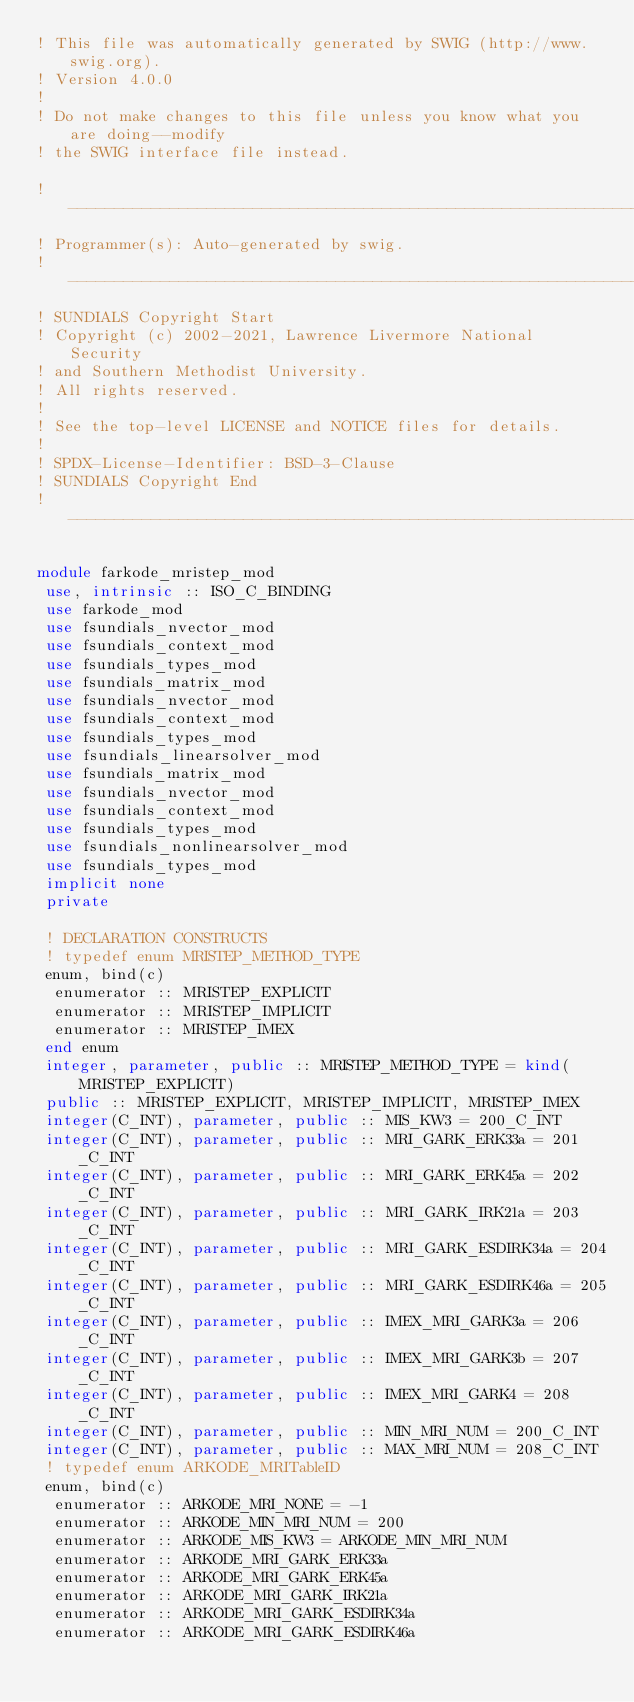Convert code to text. <code><loc_0><loc_0><loc_500><loc_500><_FORTRAN_>! This file was automatically generated by SWIG (http://www.swig.org).
! Version 4.0.0
!
! Do not make changes to this file unless you know what you are doing--modify
! the SWIG interface file instead.

! ---------------------------------------------------------------
! Programmer(s): Auto-generated by swig.
! ---------------------------------------------------------------
! SUNDIALS Copyright Start
! Copyright (c) 2002-2021, Lawrence Livermore National Security
! and Southern Methodist University.
! All rights reserved.
!
! See the top-level LICENSE and NOTICE files for details.
!
! SPDX-License-Identifier: BSD-3-Clause
! SUNDIALS Copyright End
! ---------------------------------------------------------------

module farkode_mristep_mod
 use, intrinsic :: ISO_C_BINDING
 use farkode_mod
 use fsundials_nvector_mod
 use fsundials_context_mod
 use fsundials_types_mod
 use fsundials_matrix_mod
 use fsundials_nvector_mod
 use fsundials_context_mod
 use fsundials_types_mod
 use fsundials_linearsolver_mod
 use fsundials_matrix_mod
 use fsundials_nvector_mod
 use fsundials_context_mod
 use fsundials_types_mod
 use fsundials_nonlinearsolver_mod
 use fsundials_types_mod
 implicit none
 private

 ! DECLARATION CONSTRUCTS
 ! typedef enum MRISTEP_METHOD_TYPE
 enum, bind(c)
  enumerator :: MRISTEP_EXPLICIT
  enumerator :: MRISTEP_IMPLICIT
  enumerator :: MRISTEP_IMEX
 end enum
 integer, parameter, public :: MRISTEP_METHOD_TYPE = kind(MRISTEP_EXPLICIT)
 public :: MRISTEP_EXPLICIT, MRISTEP_IMPLICIT, MRISTEP_IMEX
 integer(C_INT), parameter, public :: MIS_KW3 = 200_C_INT
 integer(C_INT), parameter, public :: MRI_GARK_ERK33a = 201_C_INT
 integer(C_INT), parameter, public :: MRI_GARK_ERK45a = 202_C_INT
 integer(C_INT), parameter, public :: MRI_GARK_IRK21a = 203_C_INT
 integer(C_INT), parameter, public :: MRI_GARK_ESDIRK34a = 204_C_INT
 integer(C_INT), parameter, public :: MRI_GARK_ESDIRK46a = 205_C_INT
 integer(C_INT), parameter, public :: IMEX_MRI_GARK3a = 206_C_INT
 integer(C_INT), parameter, public :: IMEX_MRI_GARK3b = 207_C_INT
 integer(C_INT), parameter, public :: IMEX_MRI_GARK4 = 208_C_INT
 integer(C_INT), parameter, public :: MIN_MRI_NUM = 200_C_INT
 integer(C_INT), parameter, public :: MAX_MRI_NUM = 208_C_INT
 ! typedef enum ARKODE_MRITableID
 enum, bind(c)
  enumerator :: ARKODE_MRI_NONE = -1
  enumerator :: ARKODE_MIN_MRI_NUM = 200
  enumerator :: ARKODE_MIS_KW3 = ARKODE_MIN_MRI_NUM
  enumerator :: ARKODE_MRI_GARK_ERK33a
  enumerator :: ARKODE_MRI_GARK_ERK45a
  enumerator :: ARKODE_MRI_GARK_IRK21a
  enumerator :: ARKODE_MRI_GARK_ESDIRK34a
  enumerator :: ARKODE_MRI_GARK_ESDIRK46a</code> 